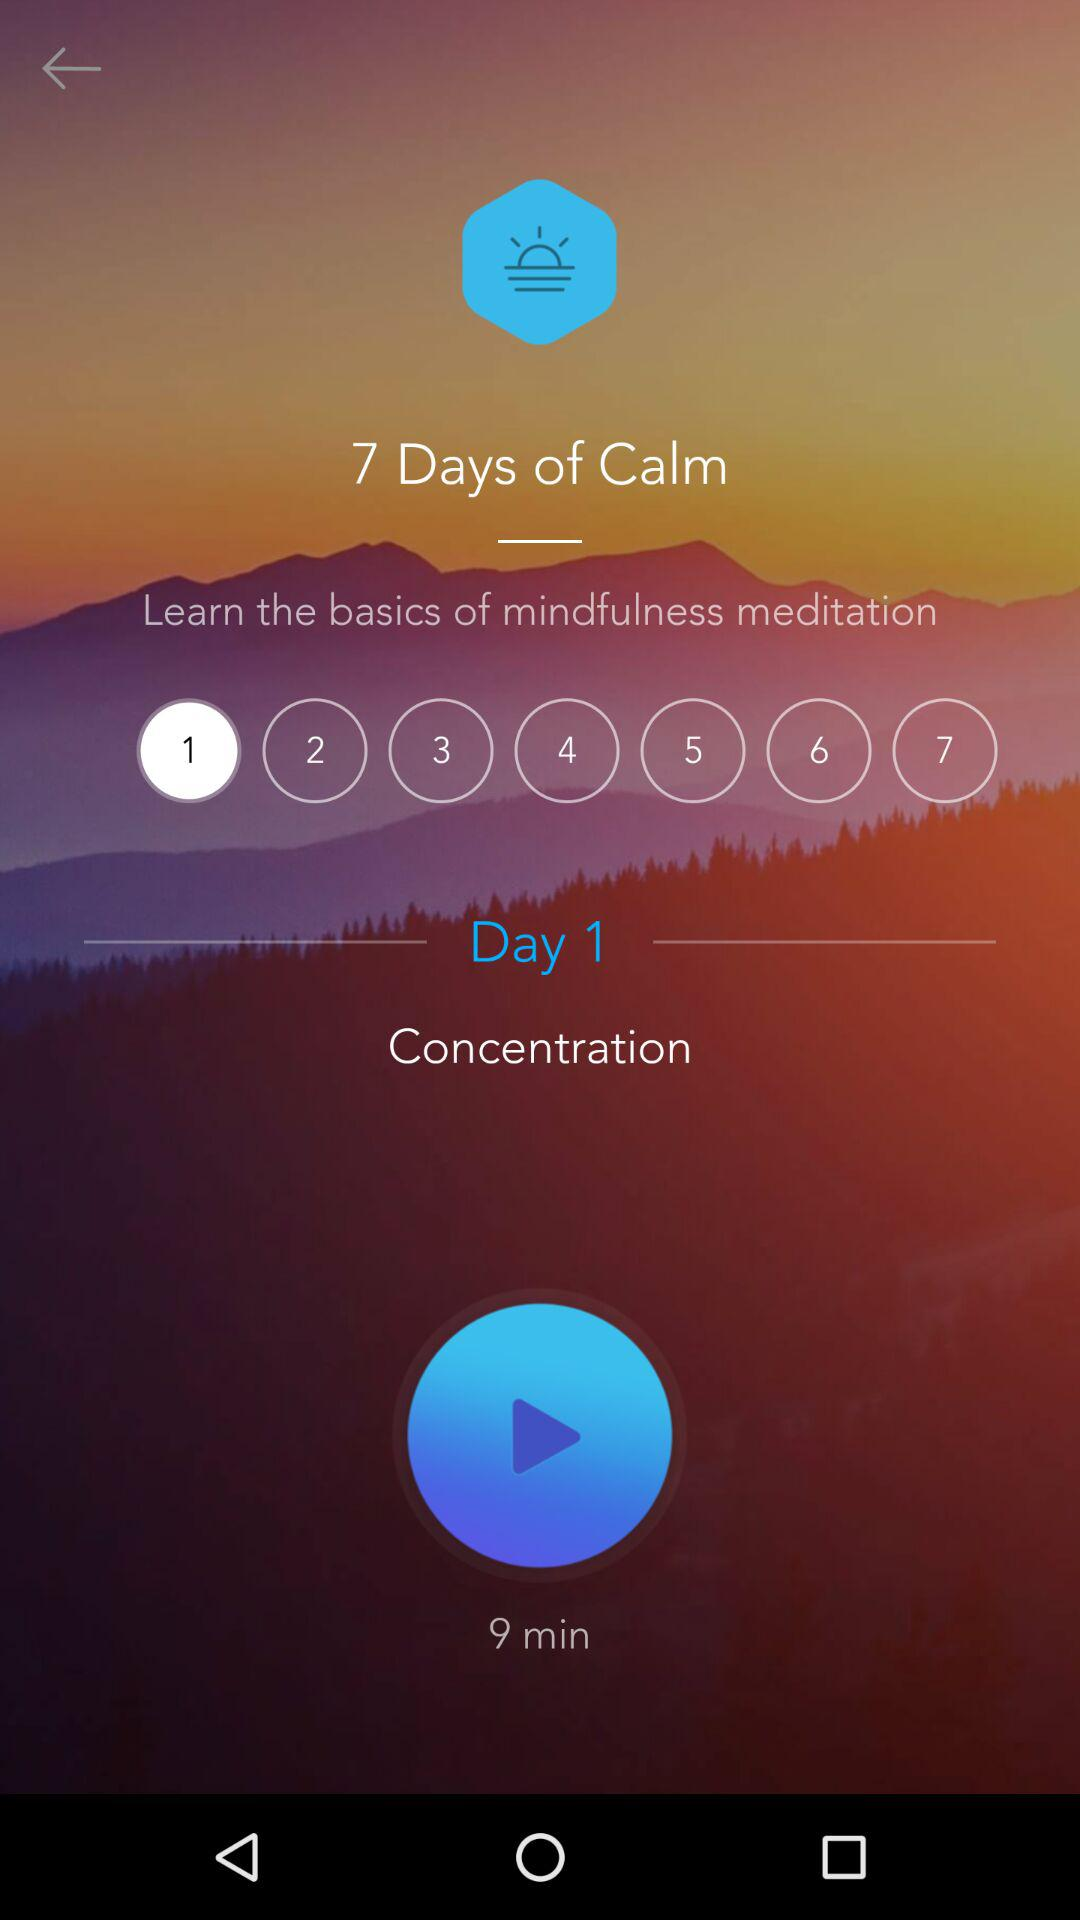What is the duration of the video?
When the provided information is insufficient, respond with <no answer>. <no answer> 